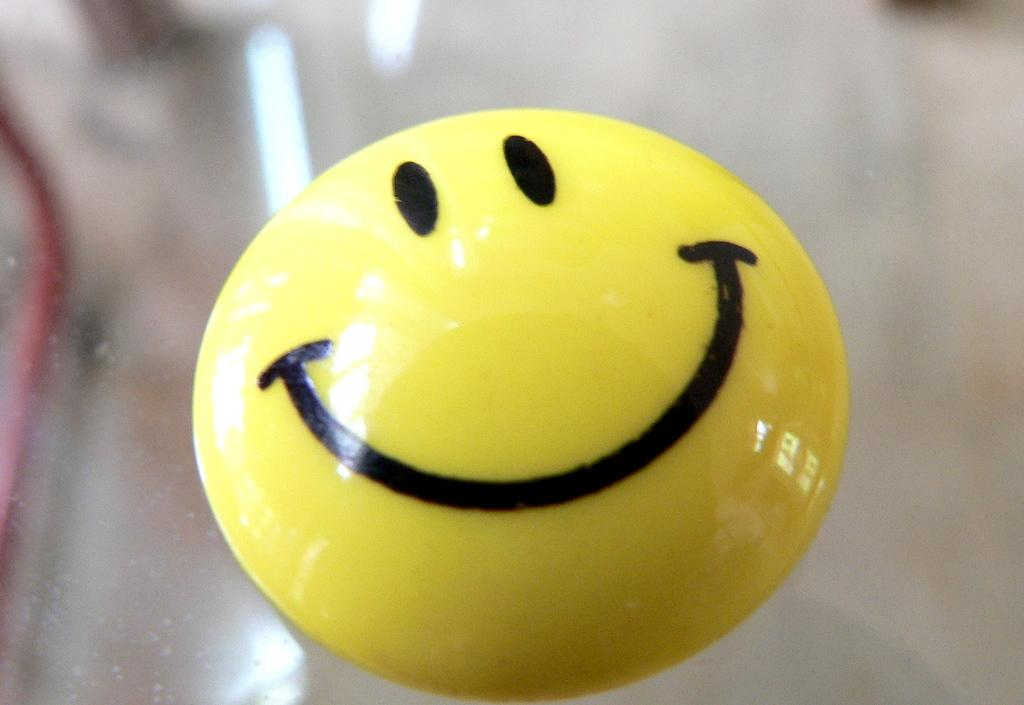What is on the glass platform in the image? There is a smiley badge on a glass platform in the image. What can be seen at the top of the image? There are reflections of lights visible at the top of the image. What else is present on the glass platform besides the smiley badge? There is an object on the glass platform. What date is marked on the calendar in the image? There is no calendar present in the image. What type of trousers are the mice wearing in the image? There are no mice or trousers present in the image. 